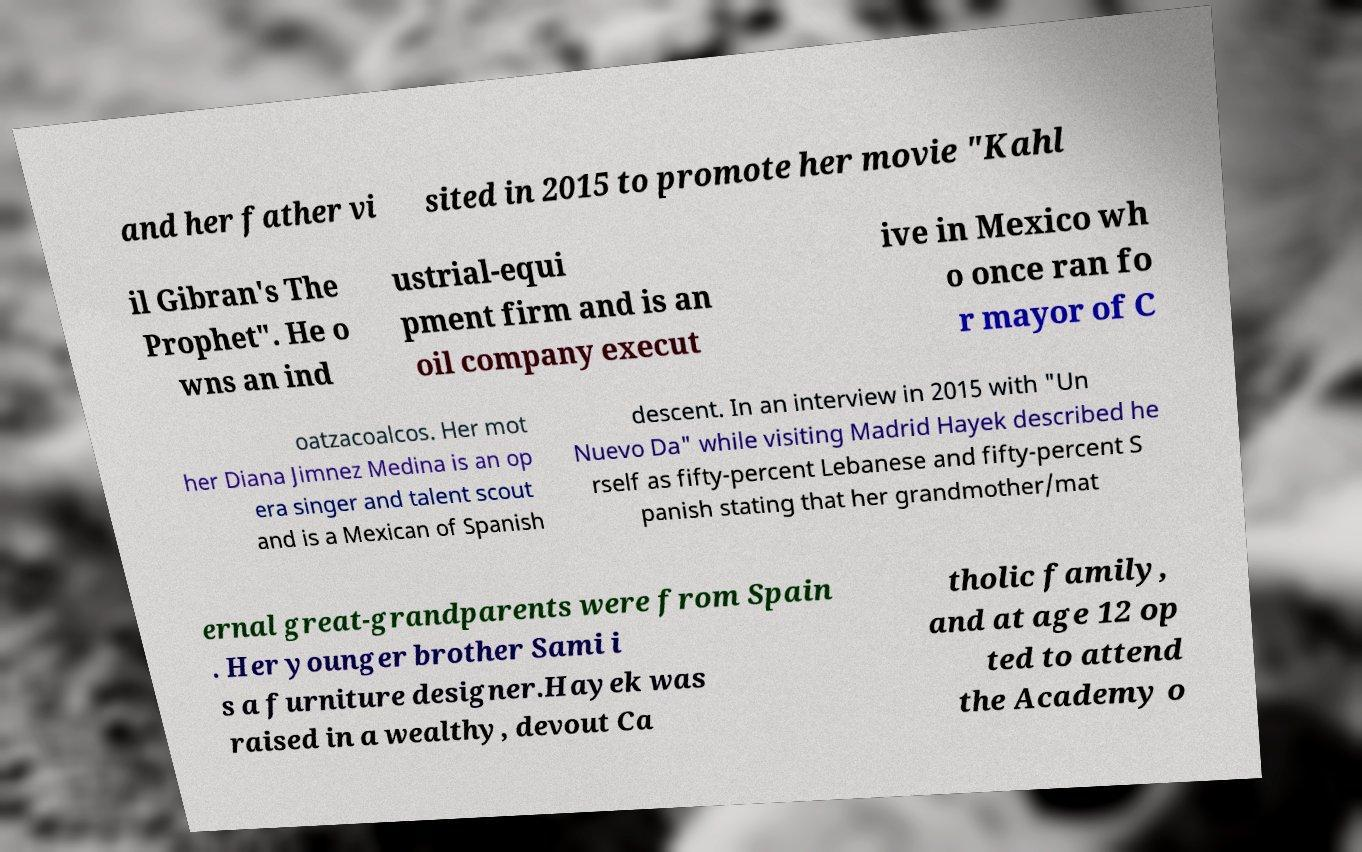Could you extract and type out the text from this image? and her father vi sited in 2015 to promote her movie "Kahl il Gibran's The Prophet". He o wns an ind ustrial-equi pment firm and is an oil company execut ive in Mexico wh o once ran fo r mayor of C oatzacoalcos. Her mot her Diana Jimnez Medina is an op era singer and talent scout and is a Mexican of Spanish descent. In an interview in 2015 with "Un Nuevo Da" while visiting Madrid Hayek described he rself as fifty-percent Lebanese and fifty-percent S panish stating that her grandmother/mat ernal great-grandparents were from Spain . Her younger brother Sami i s a furniture designer.Hayek was raised in a wealthy, devout Ca tholic family, and at age 12 op ted to attend the Academy o 